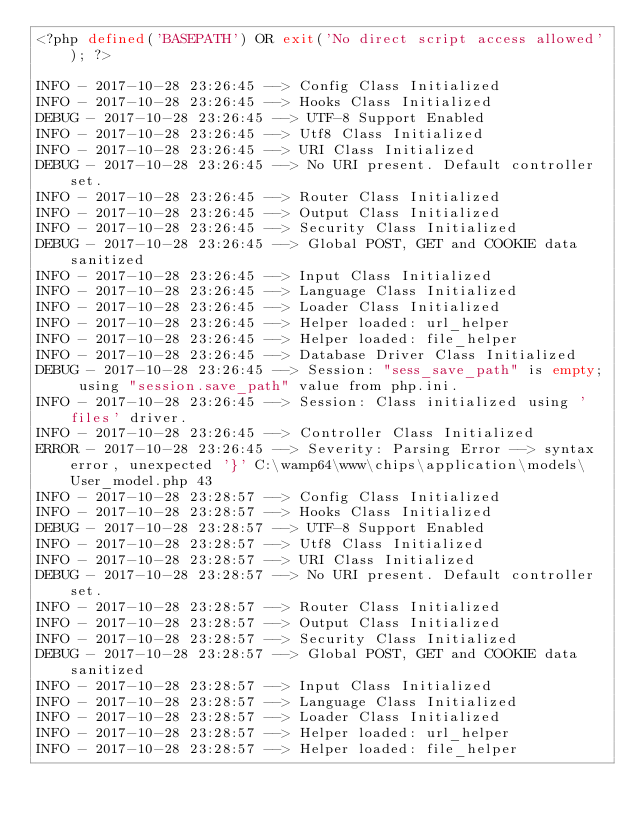Convert code to text. <code><loc_0><loc_0><loc_500><loc_500><_PHP_><?php defined('BASEPATH') OR exit('No direct script access allowed'); ?>

INFO - 2017-10-28 23:26:45 --> Config Class Initialized
INFO - 2017-10-28 23:26:45 --> Hooks Class Initialized
DEBUG - 2017-10-28 23:26:45 --> UTF-8 Support Enabled
INFO - 2017-10-28 23:26:45 --> Utf8 Class Initialized
INFO - 2017-10-28 23:26:45 --> URI Class Initialized
DEBUG - 2017-10-28 23:26:45 --> No URI present. Default controller set.
INFO - 2017-10-28 23:26:45 --> Router Class Initialized
INFO - 2017-10-28 23:26:45 --> Output Class Initialized
INFO - 2017-10-28 23:26:45 --> Security Class Initialized
DEBUG - 2017-10-28 23:26:45 --> Global POST, GET and COOKIE data sanitized
INFO - 2017-10-28 23:26:45 --> Input Class Initialized
INFO - 2017-10-28 23:26:45 --> Language Class Initialized
INFO - 2017-10-28 23:26:45 --> Loader Class Initialized
INFO - 2017-10-28 23:26:45 --> Helper loaded: url_helper
INFO - 2017-10-28 23:26:45 --> Helper loaded: file_helper
INFO - 2017-10-28 23:26:45 --> Database Driver Class Initialized
DEBUG - 2017-10-28 23:26:45 --> Session: "sess_save_path" is empty; using "session.save_path" value from php.ini.
INFO - 2017-10-28 23:26:45 --> Session: Class initialized using 'files' driver.
INFO - 2017-10-28 23:26:45 --> Controller Class Initialized
ERROR - 2017-10-28 23:26:45 --> Severity: Parsing Error --> syntax error, unexpected '}' C:\wamp64\www\chips\application\models\User_model.php 43
INFO - 2017-10-28 23:28:57 --> Config Class Initialized
INFO - 2017-10-28 23:28:57 --> Hooks Class Initialized
DEBUG - 2017-10-28 23:28:57 --> UTF-8 Support Enabled
INFO - 2017-10-28 23:28:57 --> Utf8 Class Initialized
INFO - 2017-10-28 23:28:57 --> URI Class Initialized
DEBUG - 2017-10-28 23:28:57 --> No URI present. Default controller set.
INFO - 2017-10-28 23:28:57 --> Router Class Initialized
INFO - 2017-10-28 23:28:57 --> Output Class Initialized
INFO - 2017-10-28 23:28:57 --> Security Class Initialized
DEBUG - 2017-10-28 23:28:57 --> Global POST, GET and COOKIE data sanitized
INFO - 2017-10-28 23:28:57 --> Input Class Initialized
INFO - 2017-10-28 23:28:57 --> Language Class Initialized
INFO - 2017-10-28 23:28:57 --> Loader Class Initialized
INFO - 2017-10-28 23:28:57 --> Helper loaded: url_helper
INFO - 2017-10-28 23:28:57 --> Helper loaded: file_helper</code> 